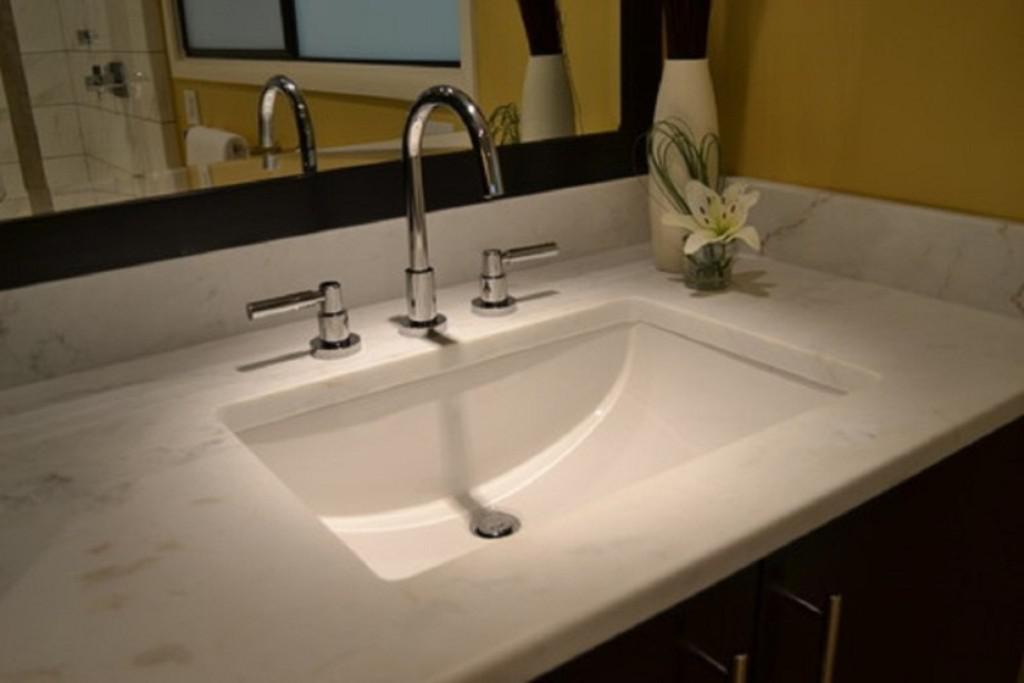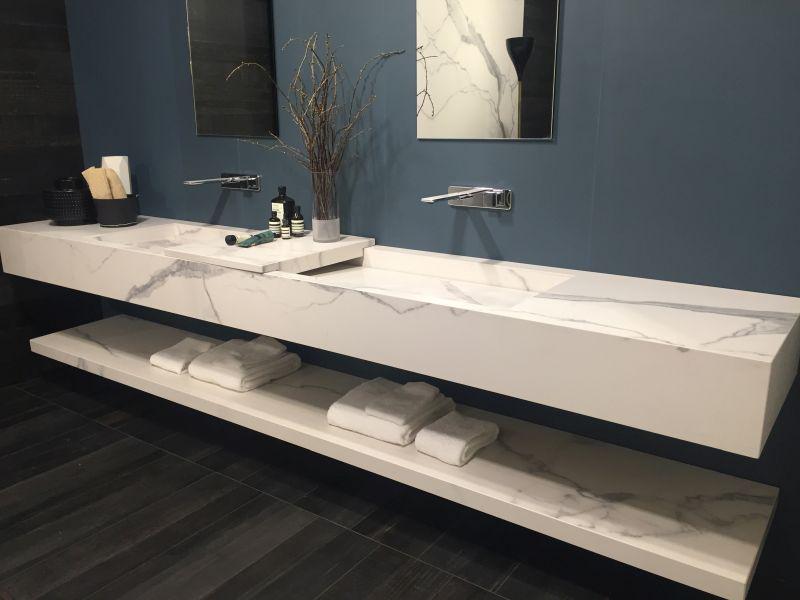The first image is the image on the left, the second image is the image on the right. Analyze the images presented: Is the assertion "One image shows a single sink and the other shows two adjacent sinks." valid? Answer yes or no. Yes. The first image is the image on the left, the second image is the image on the right. Examine the images to the left and right. Is the description "One image shows a single rectangular sink inset in a long white counter, and the other image features two white horizontal elements." accurate? Answer yes or no. Yes. 